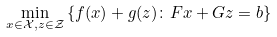<formula> <loc_0><loc_0><loc_500><loc_500>\min _ { x \in \mathcal { X } , z \in \mathcal { Z } } & \left \{ f ( x ) + g ( z ) \colon F x + G z = b \right \}</formula> 